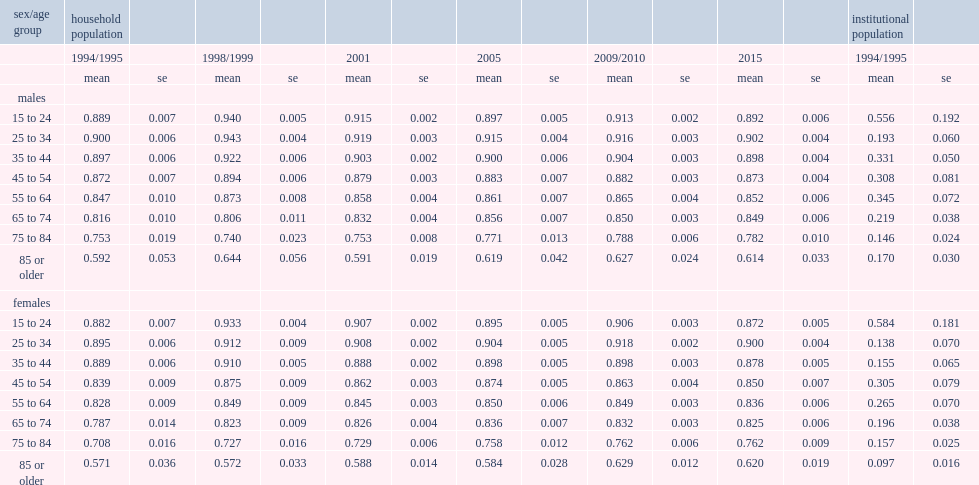In which year is the average hui3 higher for men aged 65 to 74 in the household population, 2015 or 1994/1995? 2015.0. In which year is the average hui3 higher for women aged 65 to 74 in the household population, 2015 or 1994/1995? 2015.0. In which year is the average hui3 higher for men aged 75 to 84 in the household population, 2015 or 1994/1995? 2015.0. In which year is the average hui3 higher for women aged 75 to 84 in the household population, 2015 or 1994/1995? 2015.0. In which year is the average hui3 higher for men aged 85 or older in the household population, 2015 or 1994/1995? 2015.0. In which year is the average hui3 higher for women aged 85 or older in the household population, 2015 or 1994/1995? 2015.0. What is the average hui3 for men aged 75 to 84 for the institutional population in 1994/1995? 0.146. What is the average hui3 for men aged 75 to 84 for the household population in 1994/1995? 0.753. What is the average hui3 for men aged 85 or older for the institutional population in 1994/1995? 0.17. What is the average hui3 for men aged 85 or older for the household population in 1994/1995? 0.592. What is the average hui3 for women aged 75 to 84 for the institutional population in 1994/1995? 0.157. What is the average hui3 for women aged 75 to 84 for the household population in 1994/1995? 0.708. What is the average hui3 for women aged 85 or older for the institutional population in 1994/1995? 0.097. What is the average hui3 for women aged 85 or older for the household population in 1994/1995? 0.571. 